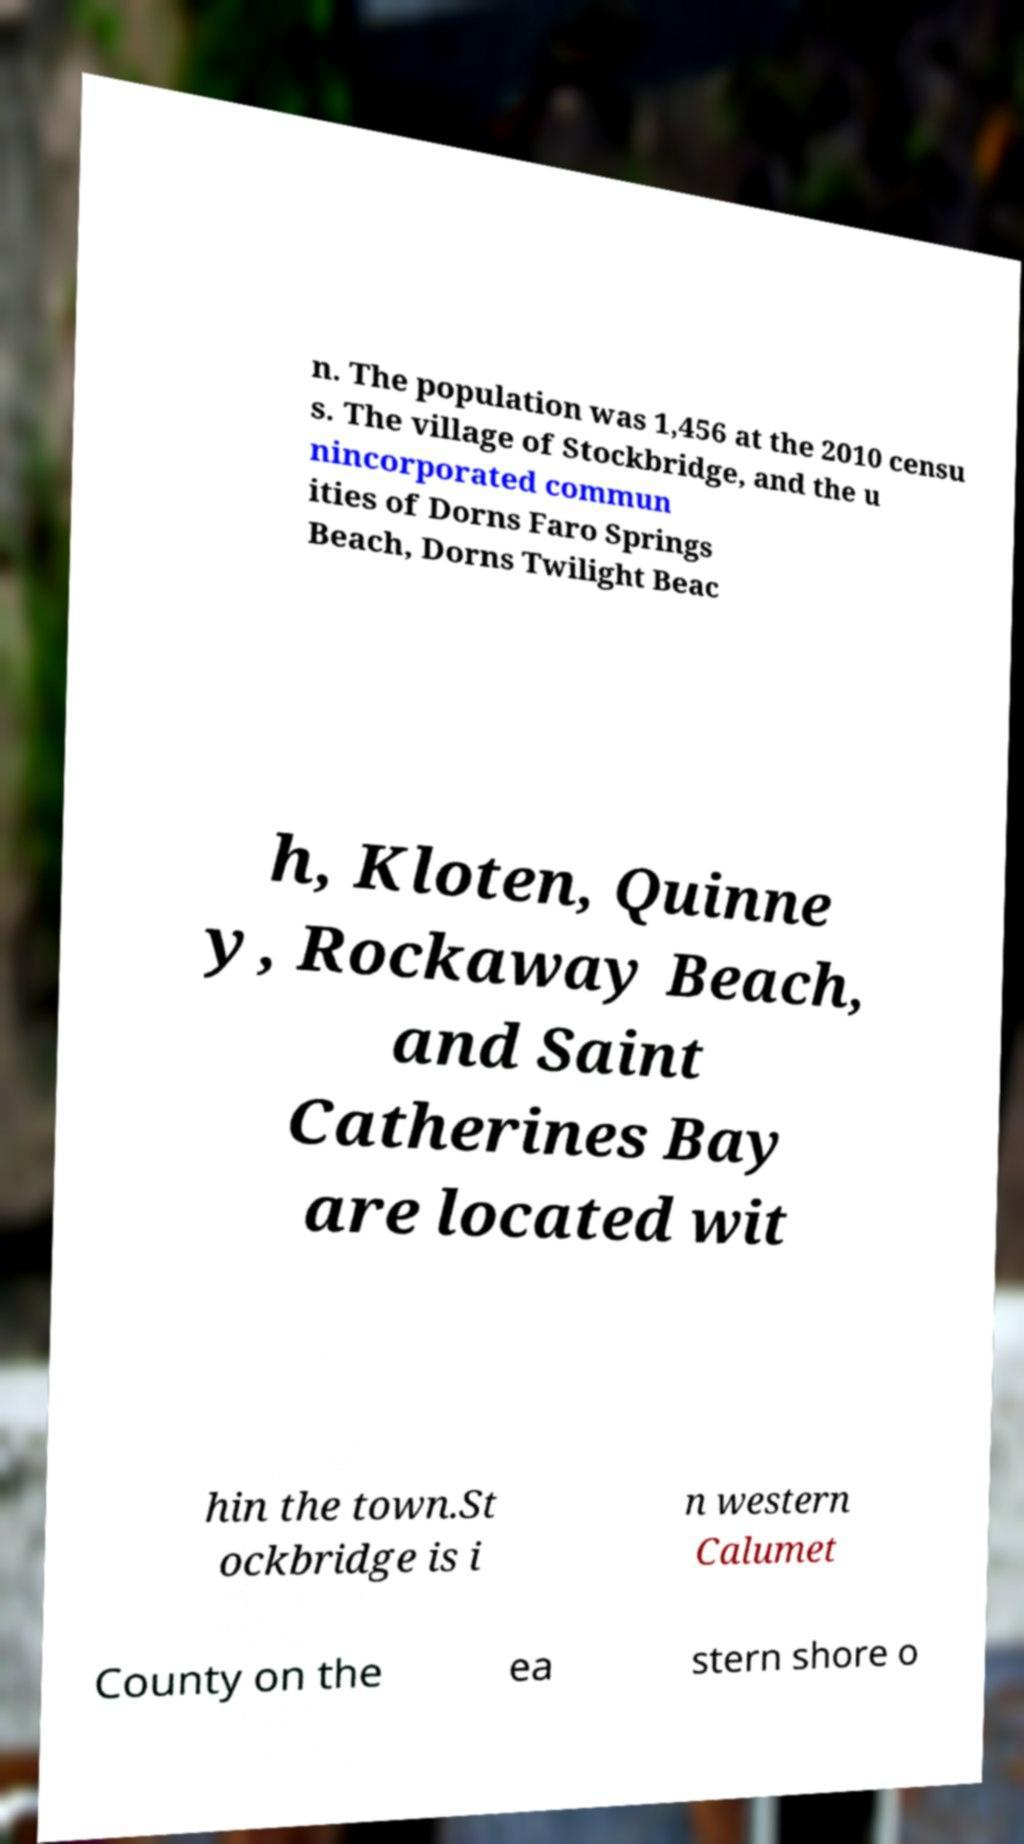What messages or text are displayed in this image? I need them in a readable, typed format. n. The population was 1,456 at the 2010 censu s. The village of Stockbridge, and the u nincorporated commun ities of Dorns Faro Springs Beach, Dorns Twilight Beac h, Kloten, Quinne y, Rockaway Beach, and Saint Catherines Bay are located wit hin the town.St ockbridge is i n western Calumet County on the ea stern shore o 